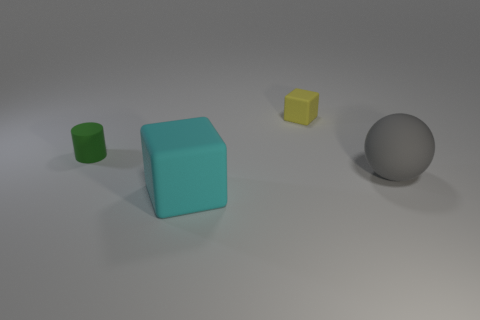What can you infer about the light source based on the shadows in the image? The shadows cast by the objects are on the right side and slightly to the front, indicating that the light source is positioned to the left, above, and slightly behind the objects. It seems to be a single light source, judging by the uniformity of the shadows. 